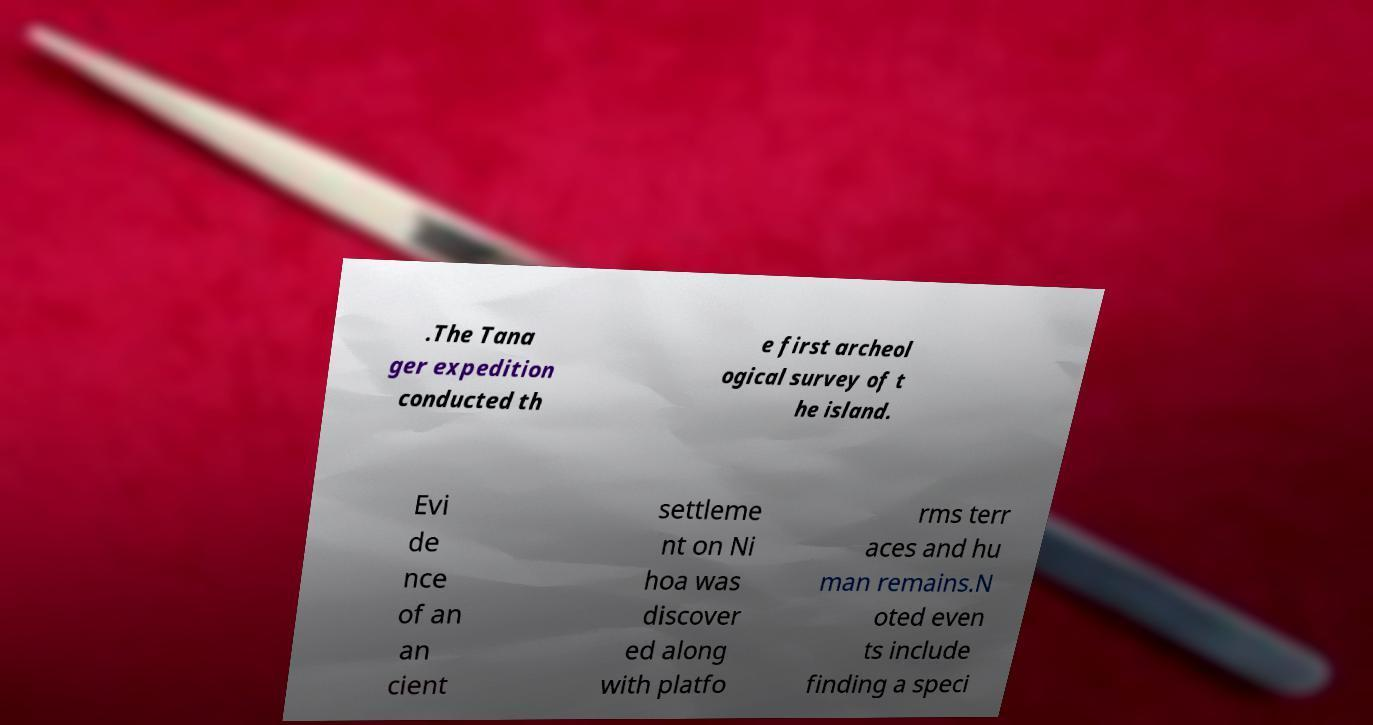Could you extract and type out the text from this image? .The Tana ger expedition conducted th e first archeol ogical survey of t he island. Evi de nce of an an cient settleme nt on Ni hoa was discover ed along with platfo rms terr aces and hu man remains.N oted even ts include finding a speci 